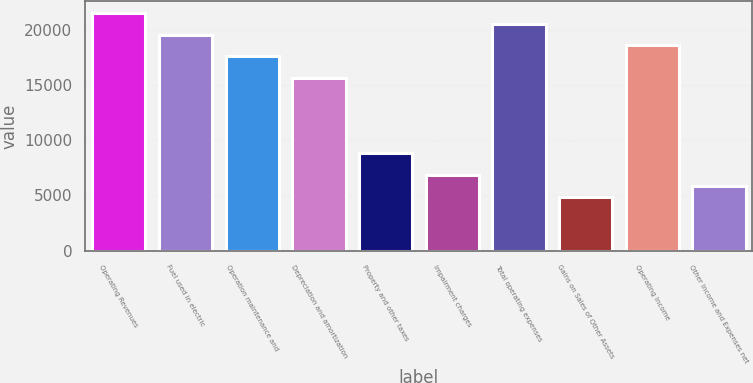Convert chart to OTSL. <chart><loc_0><loc_0><loc_500><loc_500><bar_chart><fcel>Operating Revenues<fcel>Fuel used in electric<fcel>Operation maintenance and<fcel>Depreciation and amortization<fcel>Property and other taxes<fcel>Impairment charges<fcel>Total operating expenses<fcel>Gains on Sales of Other Assets<fcel>Operating Income<fcel>Other Income and Expenses net<nl><fcel>21517.8<fcel>19562<fcel>17606.2<fcel>15650.4<fcel>8805.1<fcel>6849.3<fcel>20539.9<fcel>4893.5<fcel>18584.1<fcel>5871.4<nl></chart> 